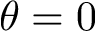<formula> <loc_0><loc_0><loc_500><loc_500>\theta = 0</formula> 